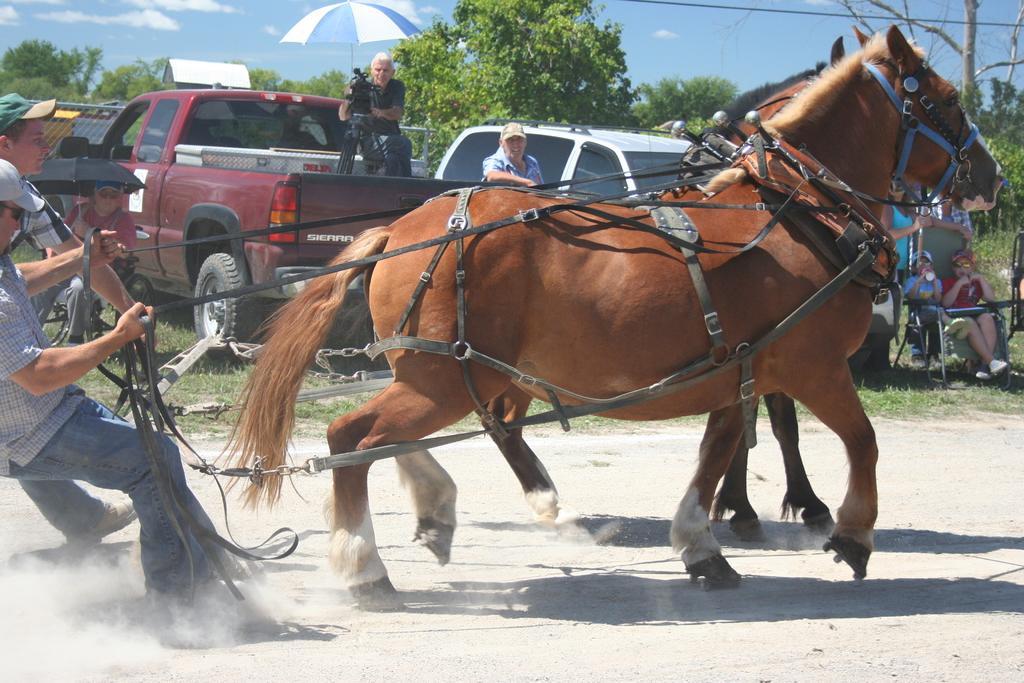In one or two sentences, can you explain what this image depicts? In this image there are two wolves running on the road. On the left two persons are holding the string attached to them. In the background there are many people. This person is holding a camera and an umbrella. In the background there are trees. 